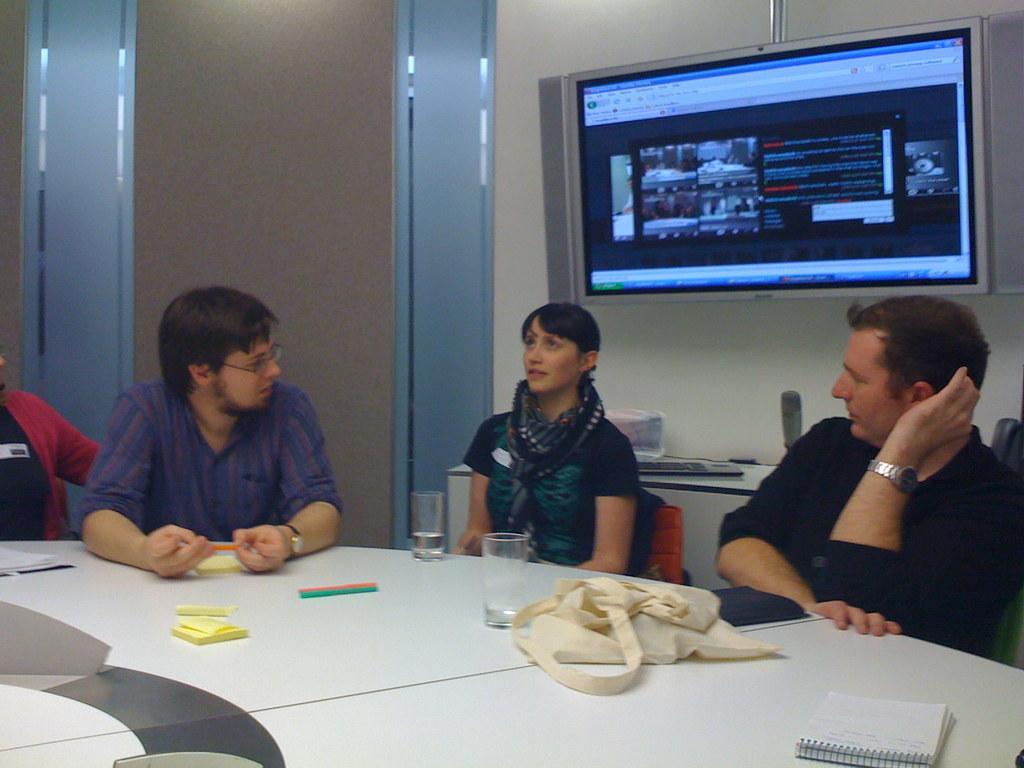Describe this image in one or two sentences. In this picture we can see man sitting on chair and beside man and woman are sitting and this woman wore scarf to her neck and in front of them there is table and on table we can see book,bag, glass and in here in background we can see wall, screen, keyboard. 